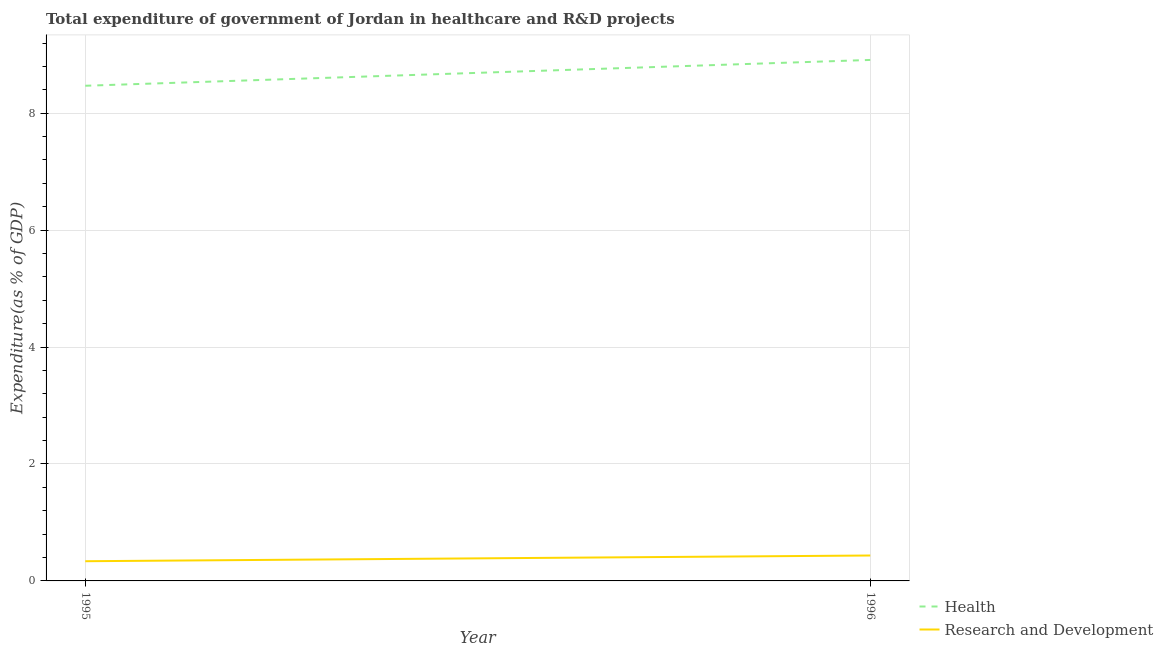Does the line corresponding to expenditure in r&d intersect with the line corresponding to expenditure in healthcare?
Make the answer very short. No. What is the expenditure in r&d in 1995?
Your answer should be very brief. 0.34. Across all years, what is the maximum expenditure in healthcare?
Provide a short and direct response. 8.91. Across all years, what is the minimum expenditure in r&d?
Make the answer very short. 0.34. In which year was the expenditure in r&d maximum?
Ensure brevity in your answer.  1996. In which year was the expenditure in healthcare minimum?
Provide a short and direct response. 1995. What is the total expenditure in r&d in the graph?
Offer a very short reply. 0.77. What is the difference between the expenditure in healthcare in 1995 and that in 1996?
Your response must be concise. -0.44. What is the difference between the expenditure in r&d in 1996 and the expenditure in healthcare in 1995?
Your answer should be very brief. -8.03. What is the average expenditure in r&d per year?
Ensure brevity in your answer.  0.39. In the year 1995, what is the difference between the expenditure in healthcare and expenditure in r&d?
Make the answer very short. 8.13. In how many years, is the expenditure in r&d greater than 2 %?
Offer a very short reply. 0. What is the ratio of the expenditure in healthcare in 1995 to that in 1996?
Make the answer very short. 0.95. In how many years, is the expenditure in healthcare greater than the average expenditure in healthcare taken over all years?
Your answer should be compact. 1. Is the expenditure in healthcare strictly less than the expenditure in r&d over the years?
Provide a short and direct response. No. Where does the legend appear in the graph?
Ensure brevity in your answer.  Bottom right. How many legend labels are there?
Offer a very short reply. 2. How are the legend labels stacked?
Your answer should be compact. Vertical. What is the title of the graph?
Provide a succinct answer. Total expenditure of government of Jordan in healthcare and R&D projects. Does "Males" appear as one of the legend labels in the graph?
Make the answer very short. No. What is the label or title of the Y-axis?
Give a very brief answer. Expenditure(as % of GDP). What is the Expenditure(as % of GDP) of Health in 1995?
Provide a succinct answer. 8.47. What is the Expenditure(as % of GDP) in Research and Development in 1995?
Give a very brief answer. 0.34. What is the Expenditure(as % of GDP) in Health in 1996?
Offer a very short reply. 8.91. What is the Expenditure(as % of GDP) in Research and Development in 1996?
Make the answer very short. 0.43. Across all years, what is the maximum Expenditure(as % of GDP) of Health?
Your answer should be compact. 8.91. Across all years, what is the maximum Expenditure(as % of GDP) in Research and Development?
Offer a very short reply. 0.43. Across all years, what is the minimum Expenditure(as % of GDP) in Health?
Your response must be concise. 8.47. Across all years, what is the minimum Expenditure(as % of GDP) in Research and Development?
Keep it short and to the point. 0.34. What is the total Expenditure(as % of GDP) in Health in the graph?
Give a very brief answer. 17.38. What is the total Expenditure(as % of GDP) in Research and Development in the graph?
Your answer should be very brief. 0.77. What is the difference between the Expenditure(as % of GDP) in Health in 1995 and that in 1996?
Your response must be concise. -0.44. What is the difference between the Expenditure(as % of GDP) in Research and Development in 1995 and that in 1996?
Ensure brevity in your answer.  -0.1. What is the difference between the Expenditure(as % of GDP) in Health in 1995 and the Expenditure(as % of GDP) in Research and Development in 1996?
Offer a terse response. 8.03. What is the average Expenditure(as % of GDP) in Health per year?
Ensure brevity in your answer.  8.69. What is the average Expenditure(as % of GDP) of Research and Development per year?
Give a very brief answer. 0.39. In the year 1995, what is the difference between the Expenditure(as % of GDP) in Health and Expenditure(as % of GDP) in Research and Development?
Ensure brevity in your answer.  8.13. In the year 1996, what is the difference between the Expenditure(as % of GDP) of Health and Expenditure(as % of GDP) of Research and Development?
Offer a very short reply. 8.48. What is the ratio of the Expenditure(as % of GDP) in Health in 1995 to that in 1996?
Give a very brief answer. 0.95. What is the ratio of the Expenditure(as % of GDP) of Research and Development in 1995 to that in 1996?
Give a very brief answer. 0.78. What is the difference between the highest and the second highest Expenditure(as % of GDP) in Health?
Provide a short and direct response. 0.44. What is the difference between the highest and the second highest Expenditure(as % of GDP) in Research and Development?
Ensure brevity in your answer.  0.1. What is the difference between the highest and the lowest Expenditure(as % of GDP) in Health?
Ensure brevity in your answer.  0.44. What is the difference between the highest and the lowest Expenditure(as % of GDP) in Research and Development?
Provide a short and direct response. 0.1. 